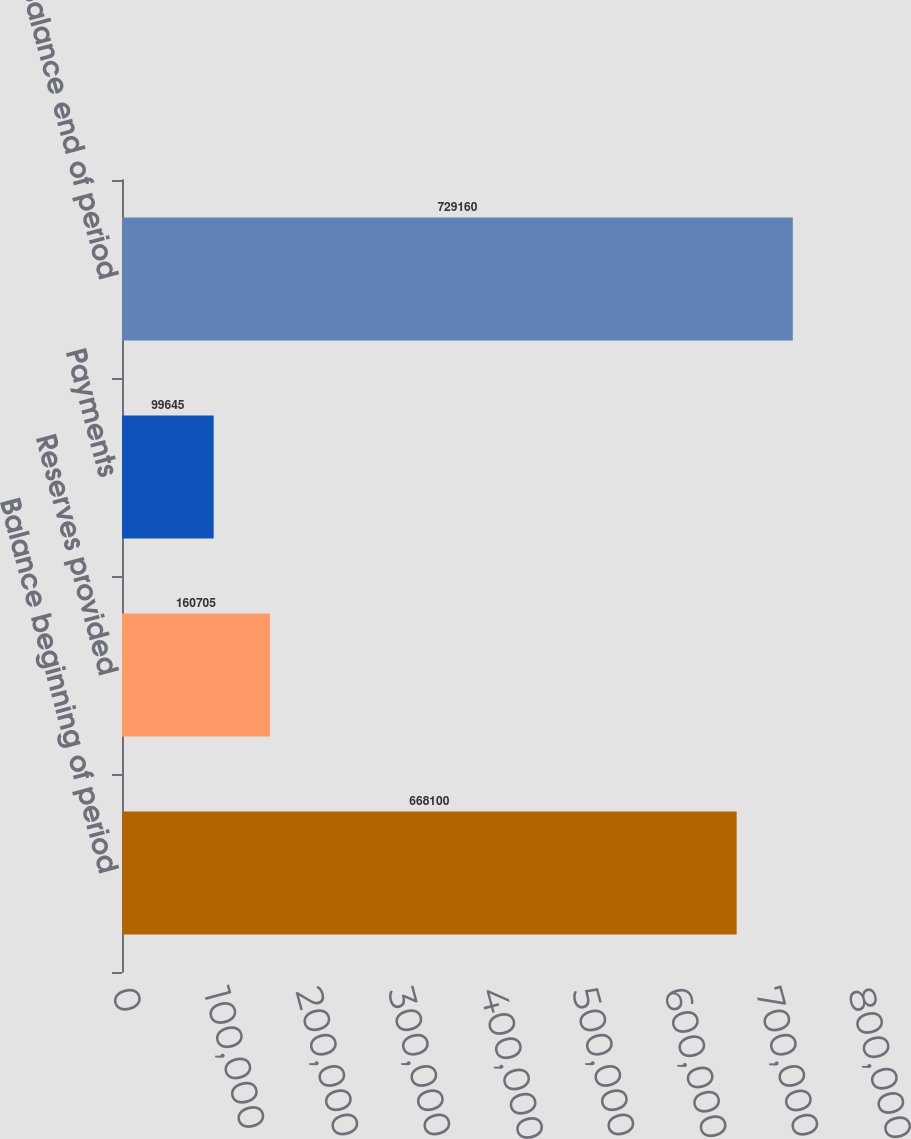<chart> <loc_0><loc_0><loc_500><loc_500><bar_chart><fcel>Balance beginning of period<fcel>Reserves provided<fcel>Payments<fcel>Balance end of period<nl><fcel>668100<fcel>160705<fcel>99645<fcel>729160<nl></chart> 